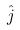Convert formula to latex. <formula><loc_0><loc_0><loc_500><loc_500>\hat { j }</formula> 